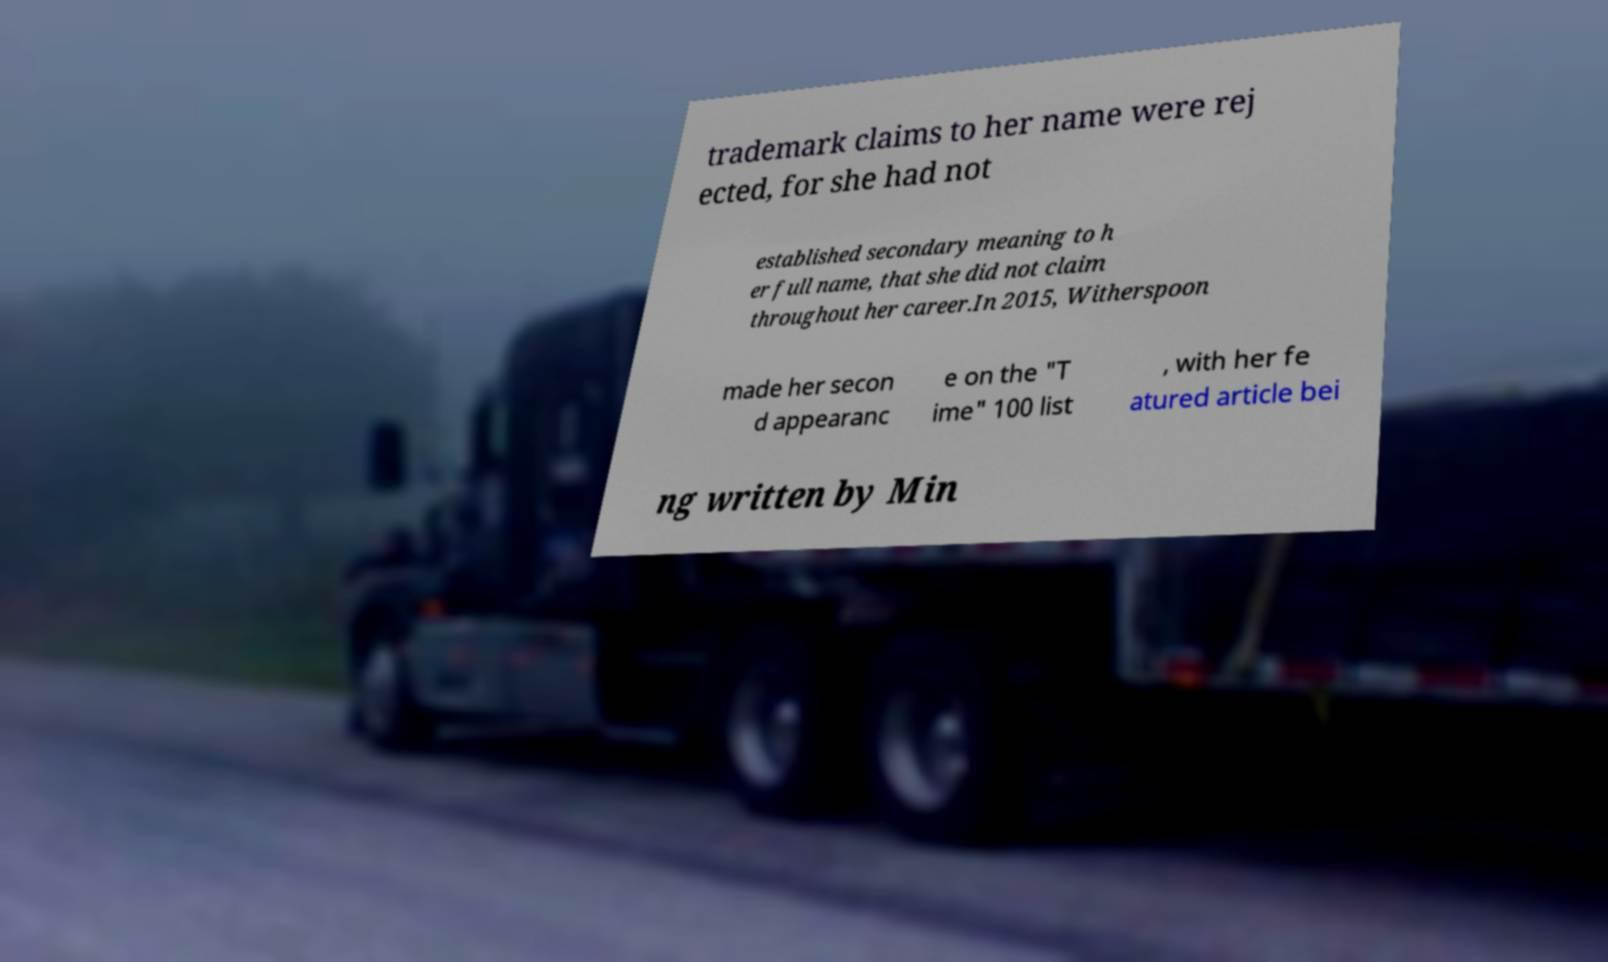I need the written content from this picture converted into text. Can you do that? trademark claims to her name were rej ected, for she had not established secondary meaning to h er full name, that she did not claim throughout her career.In 2015, Witherspoon made her secon d appearanc e on the "T ime" 100 list , with her fe atured article bei ng written by Min 